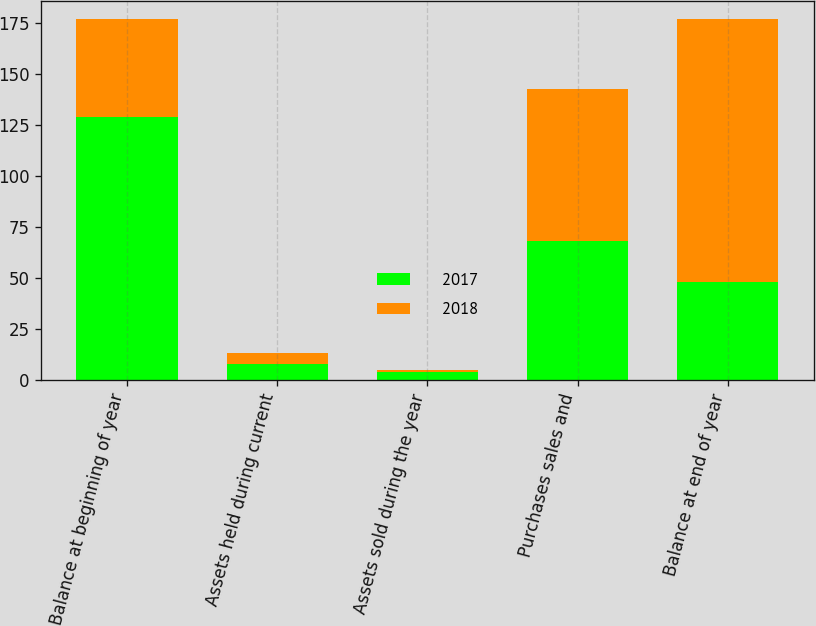<chart> <loc_0><loc_0><loc_500><loc_500><stacked_bar_chart><ecel><fcel>Balance at beginning of year<fcel>Assets held during current<fcel>Assets sold during the year<fcel>Purchases sales and<fcel>Balance at end of year<nl><fcel>2017<fcel>129<fcel>8<fcel>4<fcel>68<fcel>48<nl><fcel>2018<fcel>48<fcel>5<fcel>1<fcel>75<fcel>129<nl></chart> 